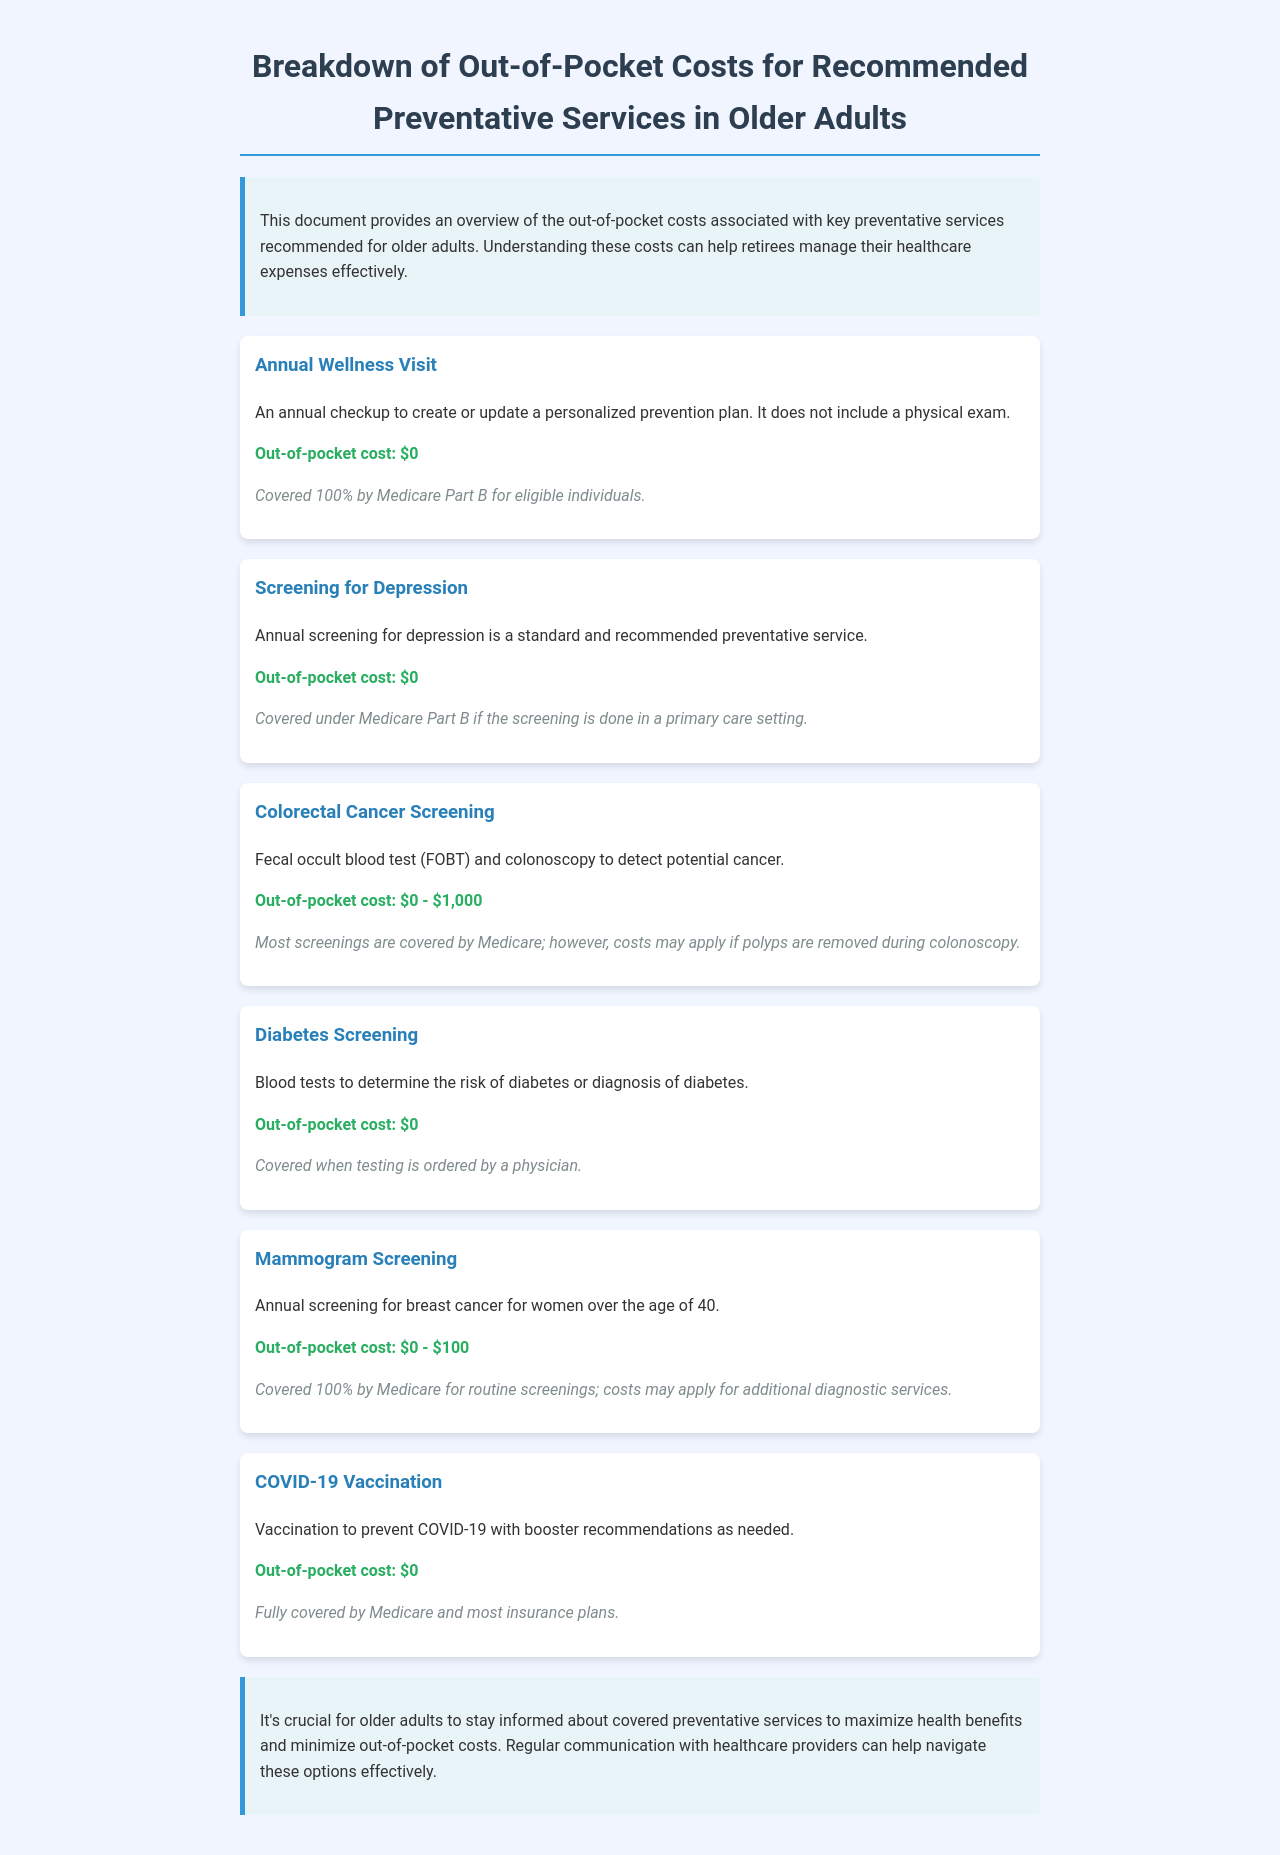What is the out-of-pocket cost for an Annual Wellness Visit? The out-of-pocket cost for an Annual Wellness Visit is stated directly in the document.
Answer: $0 What is the coverage for Colorectal Cancer Screening? The document explains that most screenings are covered by Medicare, but costs may apply if polyps are removed.
Answer: Medicare covers most screenings How much can a Mammogram Screening cost? The document lists the range of potential out-of-pocket costs associated with Mammogram Screening.
Answer: $0 - $100 What preventative service is specifically mentioned for depression? The document identifies the service related to depression screening.
Answer: Screening for Depression What is the vaccination mentioned in the document? The document specifically mentions a vaccination related to a viral disease.
Answer: COVID-19 Vaccination What is noted about Diabetes Screening coverage? The document states the condition under which Diabetes Screening is covered.
Answer: When ordered by a physician What type of document is this? The overall structure and purpose of the content indicate its specific type.
Answer: Schedule What is the main goal of the document? The introduction describes the primary purpose of providing this information.
Answer: To manage healthcare expenses effectively What service is exclusively mentioned for women over 40? The text includes a specific screening recommended for an age group.
Answer: Mammogram Screening 